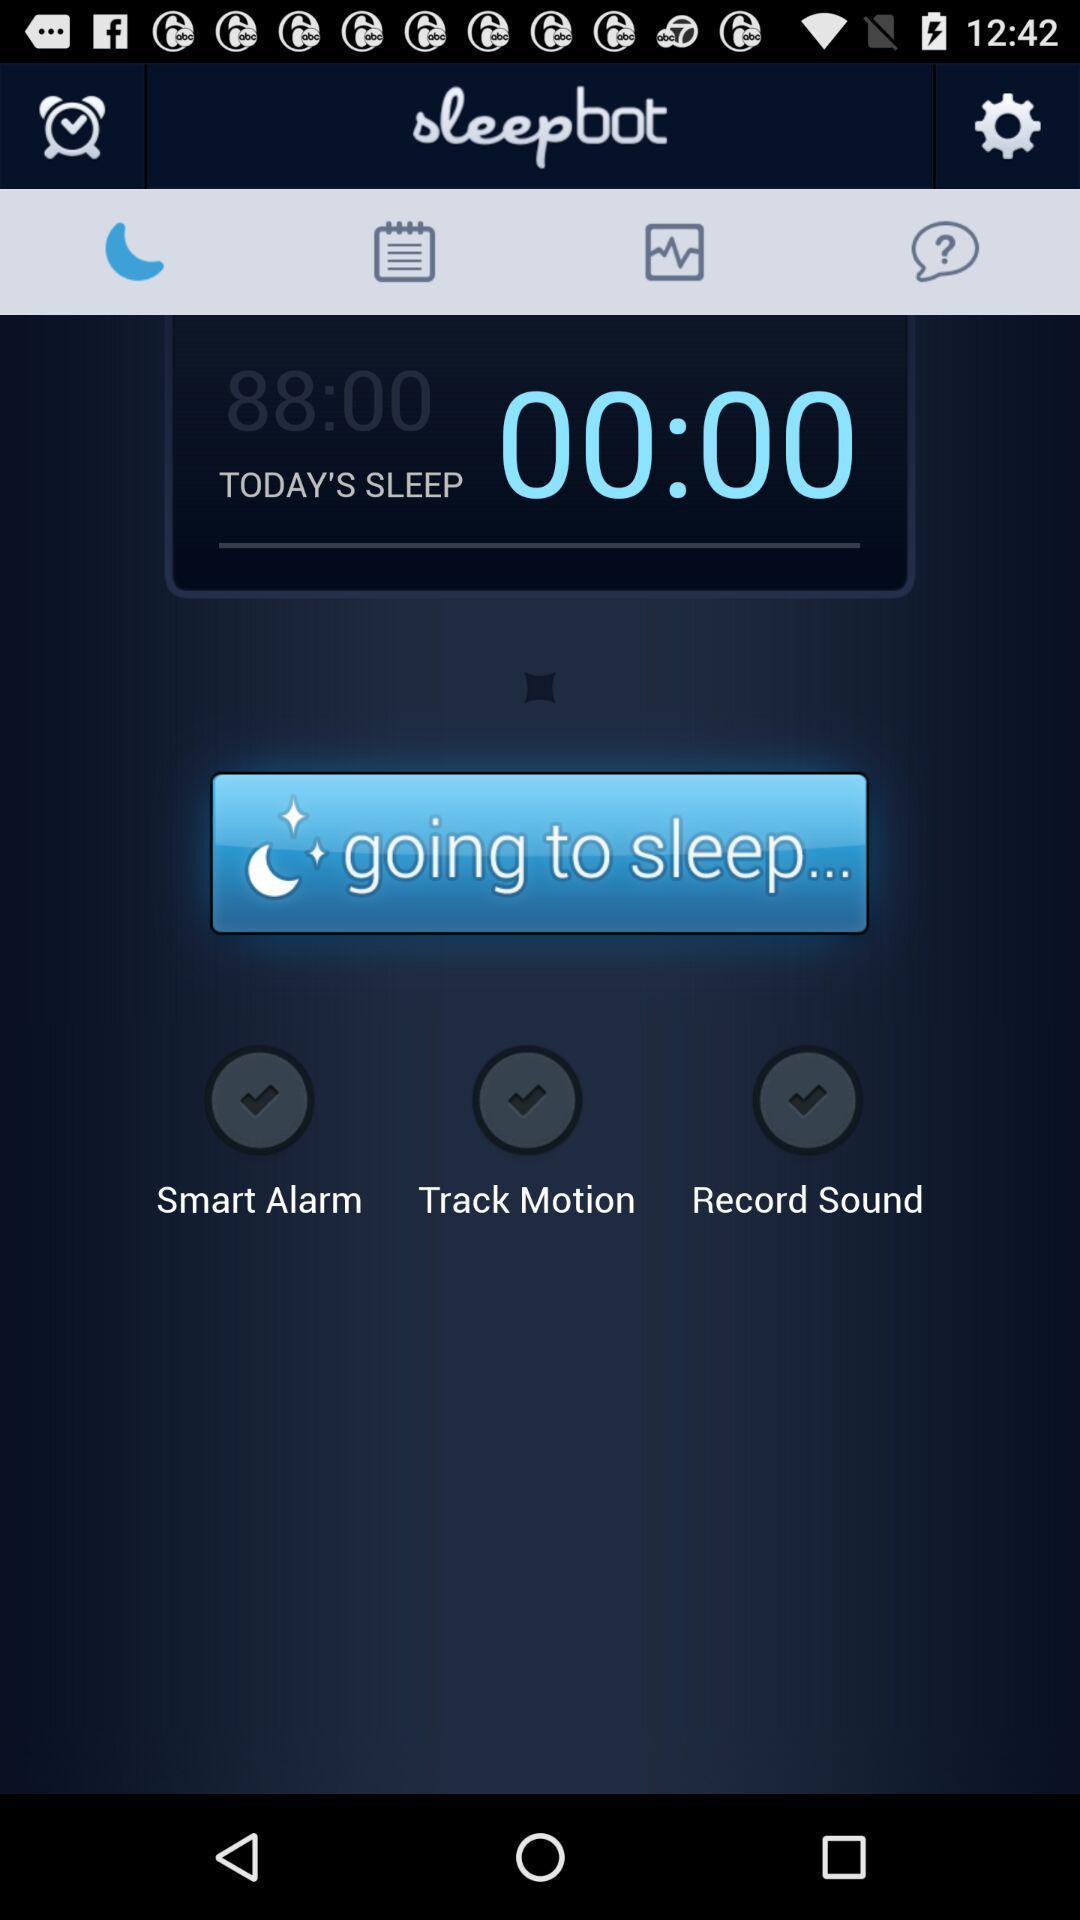Summarize the main components in this picture. Page showing timer details of sleep. 